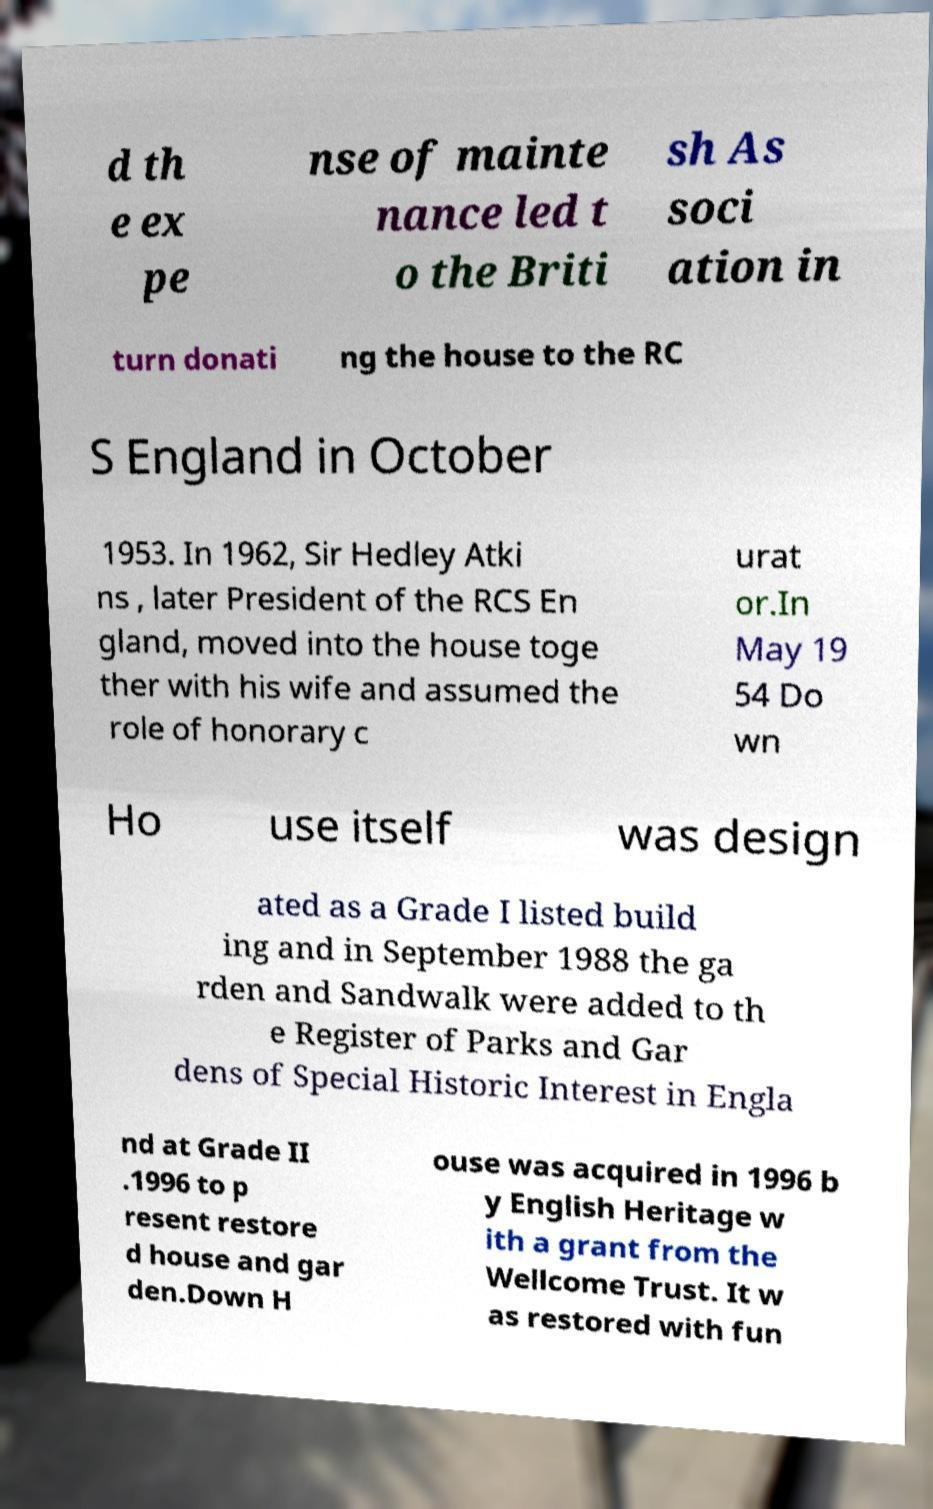Could you extract and type out the text from this image? d th e ex pe nse of mainte nance led t o the Briti sh As soci ation in turn donati ng the house to the RC S England in October 1953. In 1962, Sir Hedley Atki ns , later President of the RCS En gland, moved into the house toge ther with his wife and assumed the role of honorary c urat or.In May 19 54 Do wn Ho use itself was design ated as a Grade I listed build ing and in September 1988 the ga rden and Sandwalk were added to th e Register of Parks and Gar dens of Special Historic Interest in Engla nd at Grade II .1996 to p resent restore d house and gar den.Down H ouse was acquired in 1996 b y English Heritage w ith a grant from the Wellcome Trust. It w as restored with fun 